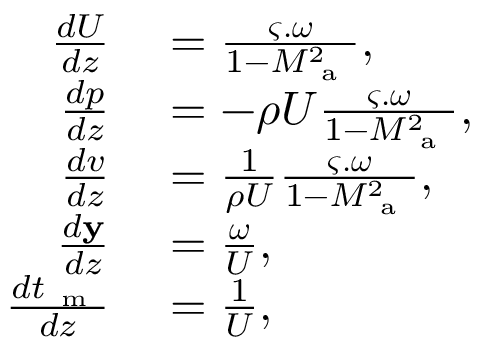Convert formula to latex. <formula><loc_0><loc_0><loc_500><loc_500>\begin{array} { r l } { \frac { d U } { d z } } & = \frac { \varsigma . \omega } { 1 - M _ { a } ^ { 2 } } , } \\ { \frac { d p } { d z } } & = - \rho U \frac { \varsigma . \omega } { 1 - M _ { a } ^ { 2 } } , } \\ { \frac { d v } { d z } } & = \frac { 1 } { \rho U } \frac { \varsigma . \omega } { 1 - M _ { a } ^ { 2 } } , } \\ { \frac { d y } { d z } } & = \frac { \omega } { U } , } \\ { \frac { d t _ { m } } { d z } } & = \frac { 1 } { U } , } \end{array}</formula> 